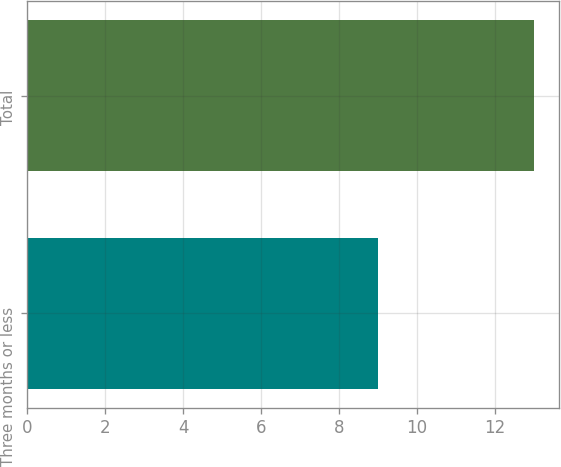Convert chart. <chart><loc_0><loc_0><loc_500><loc_500><bar_chart><fcel>Three months or less<fcel>Total<nl><fcel>9<fcel>13<nl></chart> 